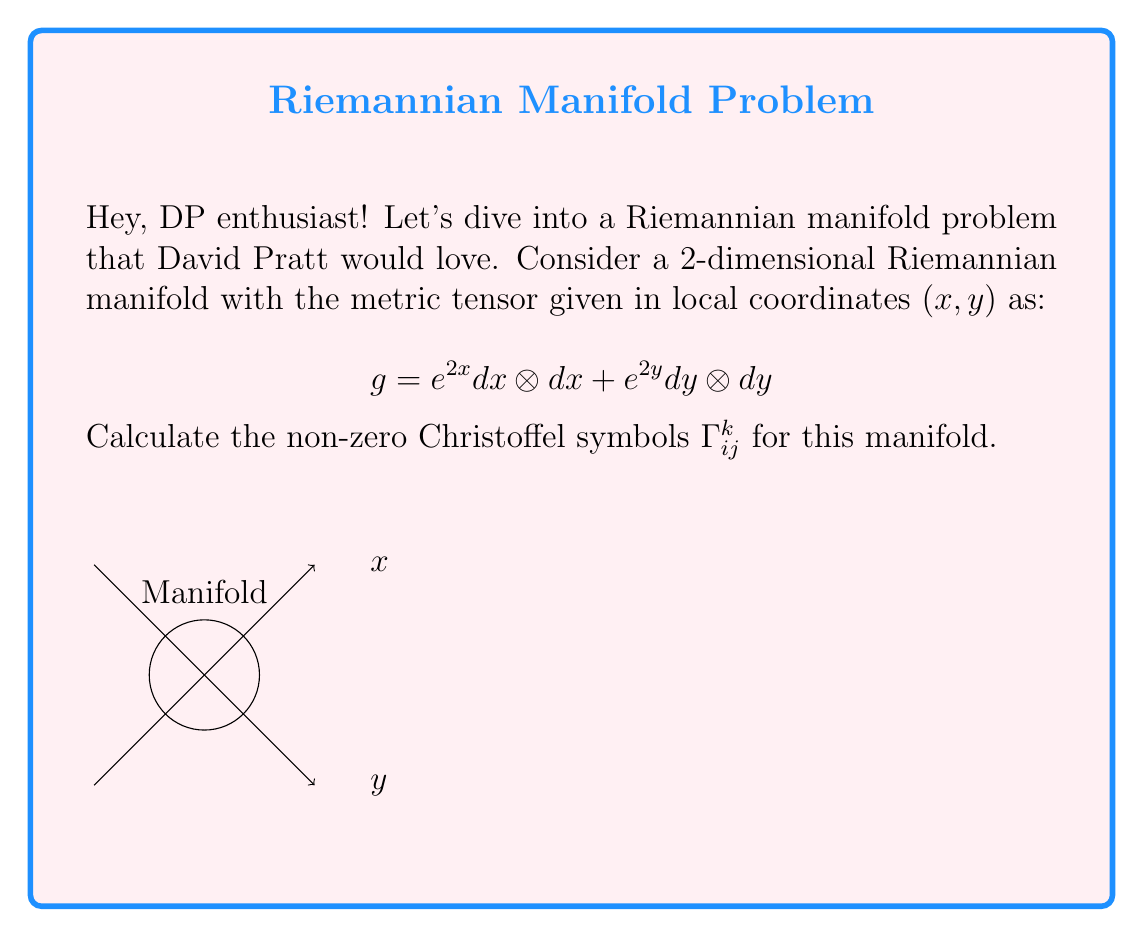Give your solution to this math problem. Let's approach this step-by-step:

1) The Christoffel symbols are given by the formula:

   $$\Gamma^k_{ij} = \frac{1}{2}g^{kl}(\partial_i g_{jl} + \partial_j g_{il} - \partial_l g_{ij})$$

2) First, we need to identify the components of the metric tensor:
   $$g_{11} = e^{2x}, \quad g_{22} = e^{2y}, \quad g_{12} = g_{21} = 0$$

3) The inverse metric tensor is:
   $$g^{11} = e^{-2x}, \quad g^{22} = e^{-2y}, \quad g^{12} = g^{21} = 0$$

4) Now, let's calculate the partial derivatives:
   $$\partial_1 g_{11} = 2e^{2x}, \quad \partial_2 g_{22} = 2e^{2y}$$
   All other partial derivatives are zero.

5) Let's calculate each non-zero Christoffel symbol:

   For $\Gamma^1_{11}$:
   $$\Gamma^1_{11} = \frac{1}{2}g^{11}(\partial_1 g_{11}) = \frac{1}{2}e^{-2x}(2e^{2x}) = 1$$

   For $\Gamma^2_{22}$:
   $$\Gamma^2_{22} = \frac{1}{2}g^{22}(\partial_2 g_{22}) = \frac{1}{2}e^{-2y}(2e^{2y}) = 1$$

6) All other Christoffel symbols are zero due to the diagonal nature of the metric and its derivatives.
Answer: $\Gamma^1_{11} = 1, \Gamma^2_{22} = 1$, all others zero. 